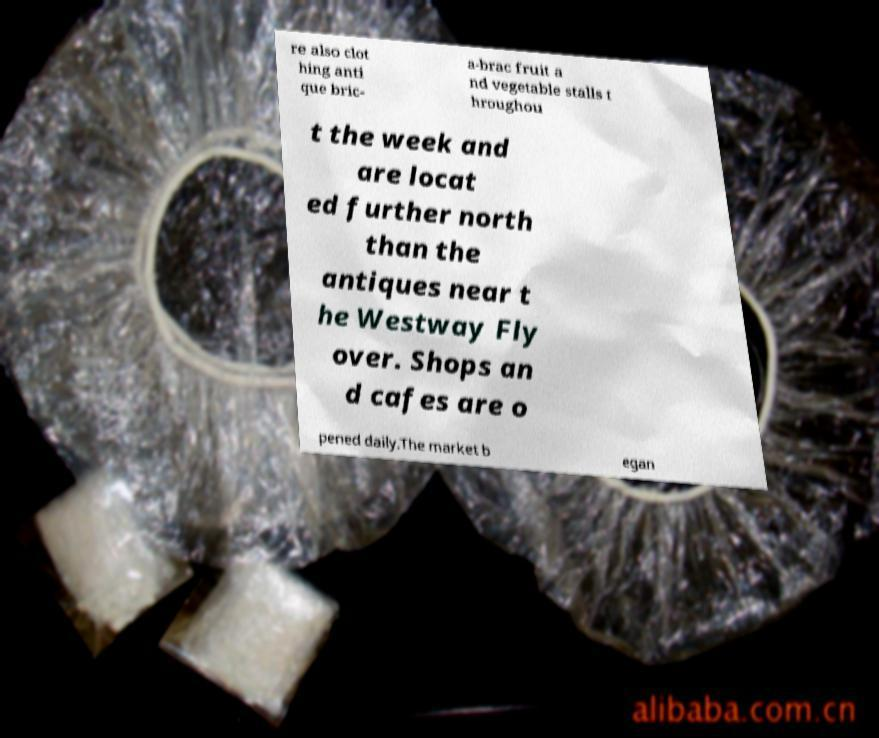Can you accurately transcribe the text from the provided image for me? re also clot hing anti que bric- a-brac fruit a nd vegetable stalls t hroughou t the week and are locat ed further north than the antiques near t he Westway Fly over. Shops an d cafes are o pened daily.The market b egan 